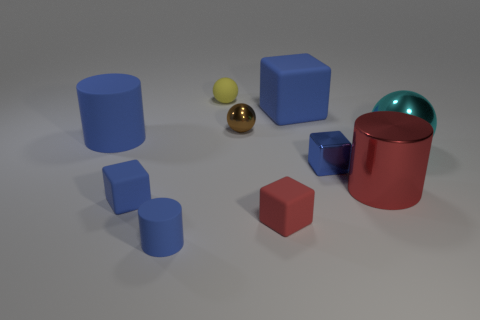Are there any repeating shapes in this image? Yes, there are repeating shapes. The cubes and cylinders are each represented multiple times, displaying variations in size and texture. 